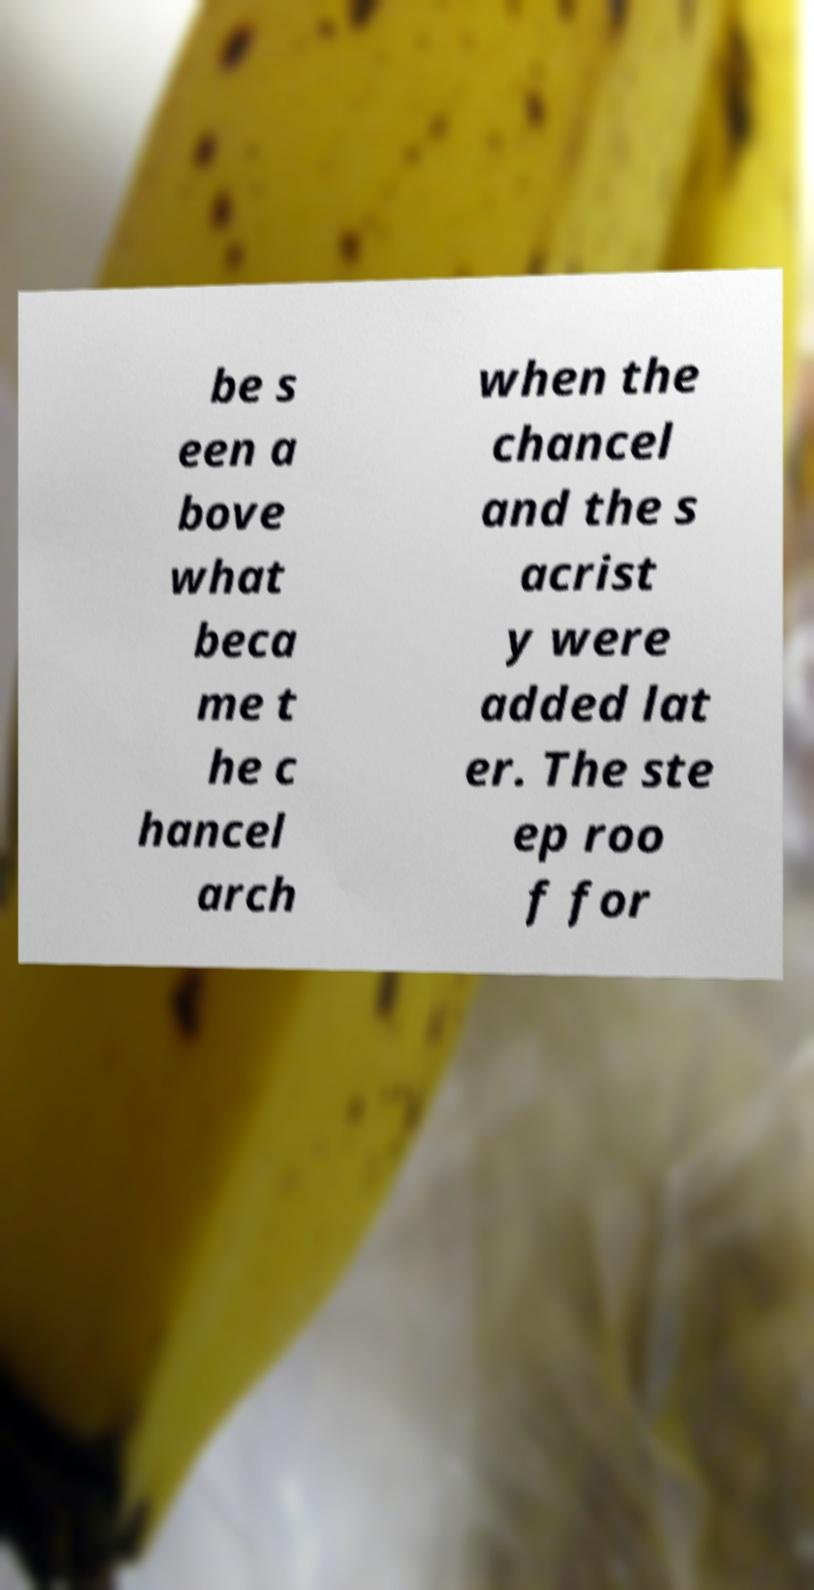Could you extract and type out the text from this image? be s een a bove what beca me t he c hancel arch when the chancel and the s acrist y were added lat er. The ste ep roo f for 